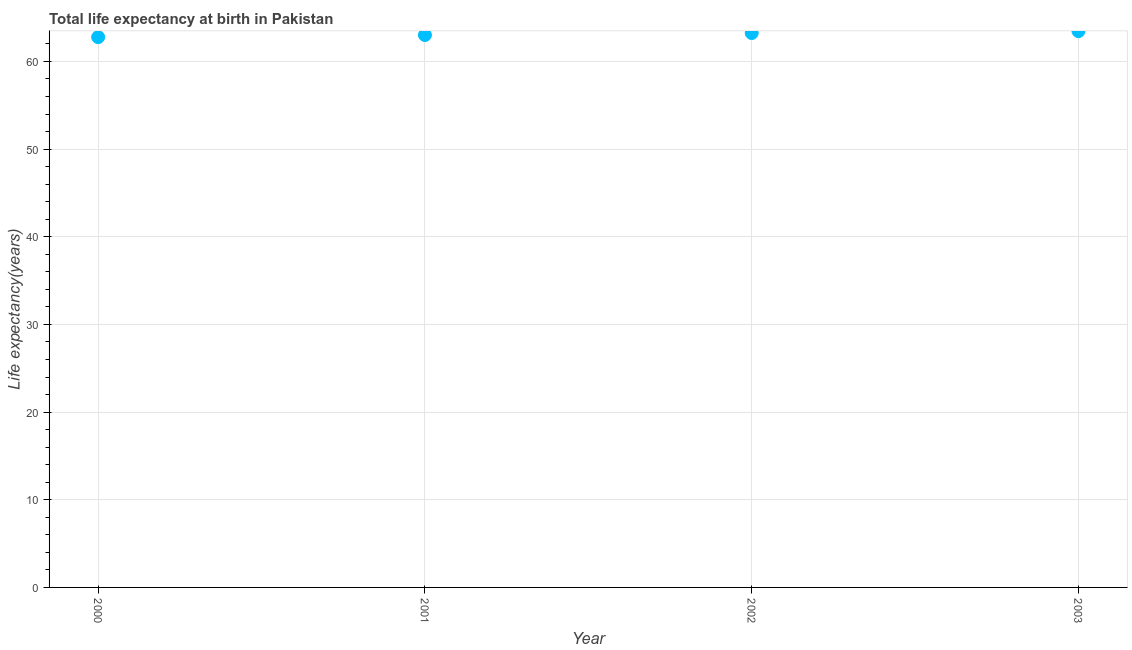What is the life expectancy at birth in 2002?
Provide a succinct answer. 63.24. Across all years, what is the maximum life expectancy at birth?
Make the answer very short. 63.46. Across all years, what is the minimum life expectancy at birth?
Keep it short and to the point. 62.77. What is the sum of the life expectancy at birth?
Provide a short and direct response. 252.49. What is the difference between the life expectancy at birth in 2000 and 2002?
Offer a very short reply. -0.47. What is the average life expectancy at birth per year?
Provide a short and direct response. 63.12. What is the median life expectancy at birth?
Provide a succinct answer. 63.13. In how many years, is the life expectancy at birth greater than 50 years?
Give a very brief answer. 4. Do a majority of the years between 2001 and 2000 (inclusive) have life expectancy at birth greater than 18 years?
Provide a short and direct response. No. What is the ratio of the life expectancy at birth in 2000 to that in 2001?
Your answer should be very brief. 1. Is the life expectancy at birth in 2002 less than that in 2003?
Offer a terse response. Yes. Is the difference between the life expectancy at birth in 2000 and 2002 greater than the difference between any two years?
Your answer should be compact. No. What is the difference between the highest and the second highest life expectancy at birth?
Give a very brief answer. 0.22. Is the sum of the life expectancy at birth in 2001 and 2003 greater than the maximum life expectancy at birth across all years?
Provide a succinct answer. Yes. What is the difference between the highest and the lowest life expectancy at birth?
Ensure brevity in your answer.  0.69. In how many years, is the life expectancy at birth greater than the average life expectancy at birth taken over all years?
Provide a succinct answer. 2. What is the difference between two consecutive major ticks on the Y-axis?
Ensure brevity in your answer.  10. Are the values on the major ticks of Y-axis written in scientific E-notation?
Provide a succinct answer. No. Does the graph contain any zero values?
Give a very brief answer. No. Does the graph contain grids?
Offer a very short reply. Yes. What is the title of the graph?
Give a very brief answer. Total life expectancy at birth in Pakistan. What is the label or title of the X-axis?
Your answer should be compact. Year. What is the label or title of the Y-axis?
Offer a terse response. Life expectancy(years). What is the Life expectancy(years) in 2000?
Your answer should be compact. 62.77. What is the Life expectancy(years) in 2001?
Your answer should be very brief. 63.01. What is the Life expectancy(years) in 2002?
Your response must be concise. 63.24. What is the Life expectancy(years) in 2003?
Provide a succinct answer. 63.46. What is the difference between the Life expectancy(years) in 2000 and 2001?
Ensure brevity in your answer.  -0.24. What is the difference between the Life expectancy(years) in 2000 and 2002?
Offer a terse response. -0.47. What is the difference between the Life expectancy(years) in 2000 and 2003?
Your answer should be very brief. -0.69. What is the difference between the Life expectancy(years) in 2001 and 2002?
Your response must be concise. -0.23. What is the difference between the Life expectancy(years) in 2001 and 2003?
Provide a succinct answer. -0.44. What is the difference between the Life expectancy(years) in 2002 and 2003?
Keep it short and to the point. -0.22. What is the ratio of the Life expectancy(years) in 2000 to that in 2001?
Offer a terse response. 1. What is the ratio of the Life expectancy(years) in 2000 to that in 2002?
Offer a terse response. 0.99. What is the ratio of the Life expectancy(years) in 2000 to that in 2003?
Offer a terse response. 0.99. What is the ratio of the Life expectancy(years) in 2001 to that in 2003?
Offer a terse response. 0.99. What is the ratio of the Life expectancy(years) in 2002 to that in 2003?
Your response must be concise. 1. 